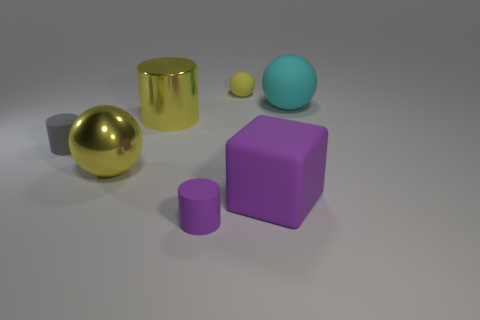Subtract all small matte cylinders. How many cylinders are left? 1 Subtract all balls. How many objects are left? 4 Add 2 yellow rubber objects. How many objects exist? 9 Add 6 cyan matte spheres. How many cyan matte spheres exist? 7 Subtract 0 red cylinders. How many objects are left? 7 Subtract all big cyan rubber objects. Subtract all small purple matte things. How many objects are left? 5 Add 6 gray objects. How many gray objects are left? 7 